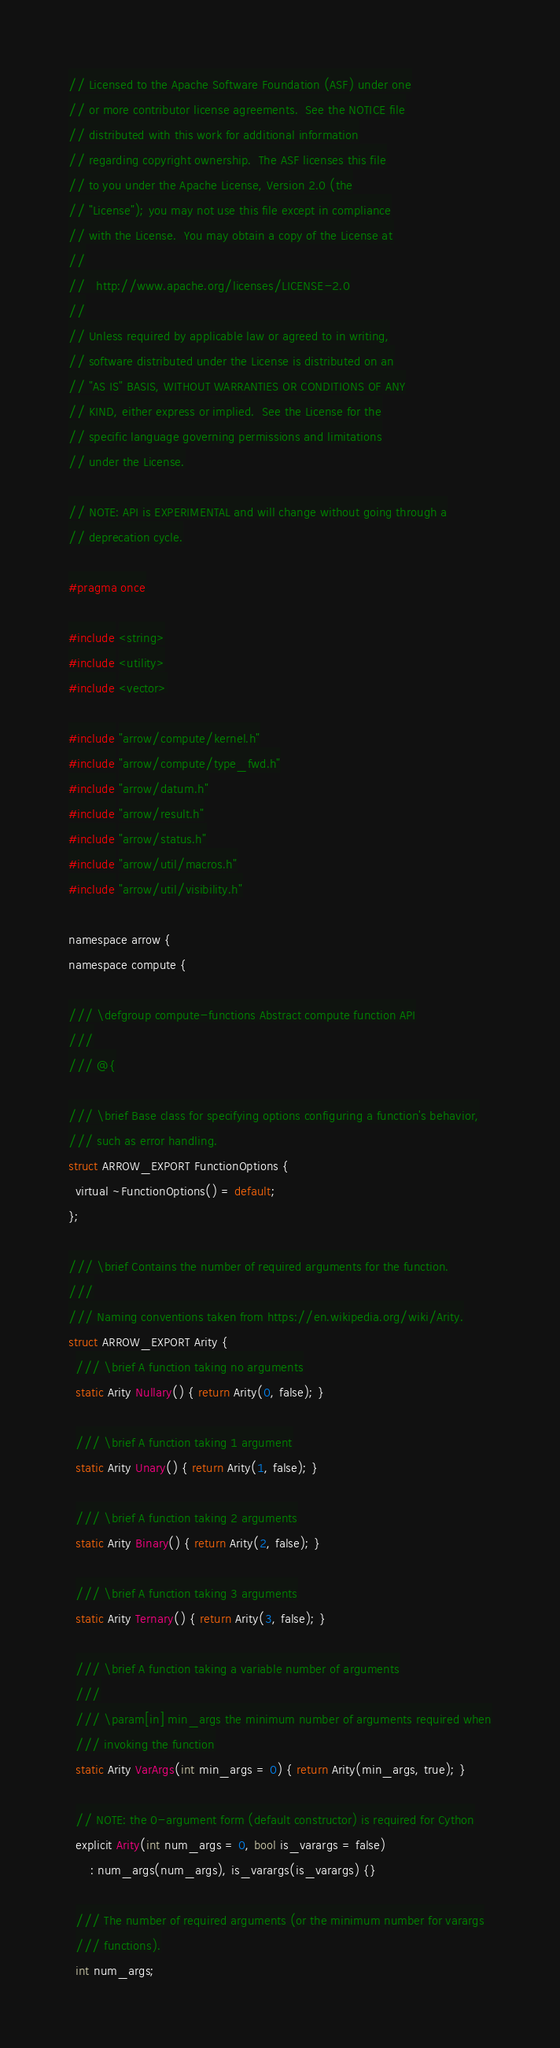Convert code to text. <code><loc_0><loc_0><loc_500><loc_500><_C_>// Licensed to the Apache Software Foundation (ASF) under one
// or more contributor license agreements.  See the NOTICE file
// distributed with this work for additional information
// regarding copyright ownership.  The ASF licenses this file
// to you under the Apache License, Version 2.0 (the
// "License"); you may not use this file except in compliance
// with the License.  You may obtain a copy of the License at
//
//   http://www.apache.org/licenses/LICENSE-2.0
//
// Unless required by applicable law or agreed to in writing,
// software distributed under the License is distributed on an
// "AS IS" BASIS, WITHOUT WARRANTIES OR CONDITIONS OF ANY
// KIND, either express or implied.  See the License for the
// specific language governing permissions and limitations
// under the License.

// NOTE: API is EXPERIMENTAL and will change without going through a
// deprecation cycle.

#pragma once

#include <string>
#include <utility>
#include <vector>

#include "arrow/compute/kernel.h"
#include "arrow/compute/type_fwd.h"
#include "arrow/datum.h"
#include "arrow/result.h"
#include "arrow/status.h"
#include "arrow/util/macros.h"
#include "arrow/util/visibility.h"

namespace arrow {
namespace compute {

/// \defgroup compute-functions Abstract compute function API
///
/// @{

/// \brief Base class for specifying options configuring a function's behavior,
/// such as error handling.
struct ARROW_EXPORT FunctionOptions {
  virtual ~FunctionOptions() = default;
};

/// \brief Contains the number of required arguments for the function.
///
/// Naming conventions taken from https://en.wikipedia.org/wiki/Arity.
struct ARROW_EXPORT Arity {
  /// \brief A function taking no arguments
  static Arity Nullary() { return Arity(0, false); }

  /// \brief A function taking 1 argument
  static Arity Unary() { return Arity(1, false); }

  /// \brief A function taking 2 arguments
  static Arity Binary() { return Arity(2, false); }

  /// \brief A function taking 3 arguments
  static Arity Ternary() { return Arity(3, false); }

  /// \brief A function taking a variable number of arguments
  ///
  /// \param[in] min_args the minimum number of arguments required when
  /// invoking the function
  static Arity VarArgs(int min_args = 0) { return Arity(min_args, true); }

  // NOTE: the 0-argument form (default constructor) is required for Cython
  explicit Arity(int num_args = 0, bool is_varargs = false)
      : num_args(num_args), is_varargs(is_varargs) {}

  /// The number of required arguments (or the minimum number for varargs
  /// functions).
  int num_args;
</code> 